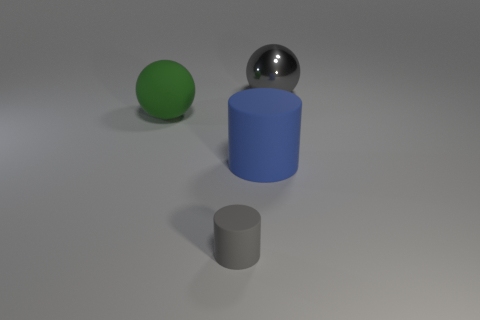Add 4 gray cylinders. How many objects exist? 8 Subtract all gray spheres. How many spheres are left? 1 Subtract 1 cylinders. How many cylinders are left? 1 Add 3 large green balls. How many large green balls exist? 4 Subtract 1 green balls. How many objects are left? 3 Subtract all cyan balls. Subtract all green cubes. How many balls are left? 2 Subtract all yellow cylinders. How many gray spheres are left? 1 Subtract all big metallic blocks. Subtract all gray objects. How many objects are left? 2 Add 2 big green rubber things. How many big green rubber things are left? 3 